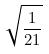<formula> <loc_0><loc_0><loc_500><loc_500>\sqrt { \frac { 1 } { 2 1 } }</formula> 